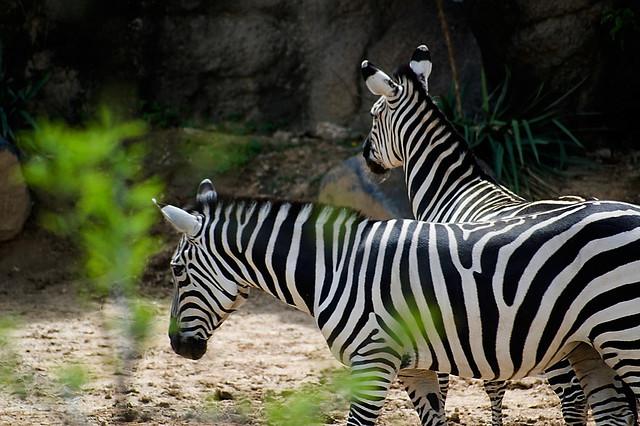Are zebras looking for food or loving each other?
Be succinct. Looking for food. Are these real zebras?
Give a very brief answer. Yes. What color are the zebras stripes?
Answer briefly. Black. Do the animals run the zoo?
Write a very short answer. No. How many zoo animals are there?
Answer briefly. 2. 